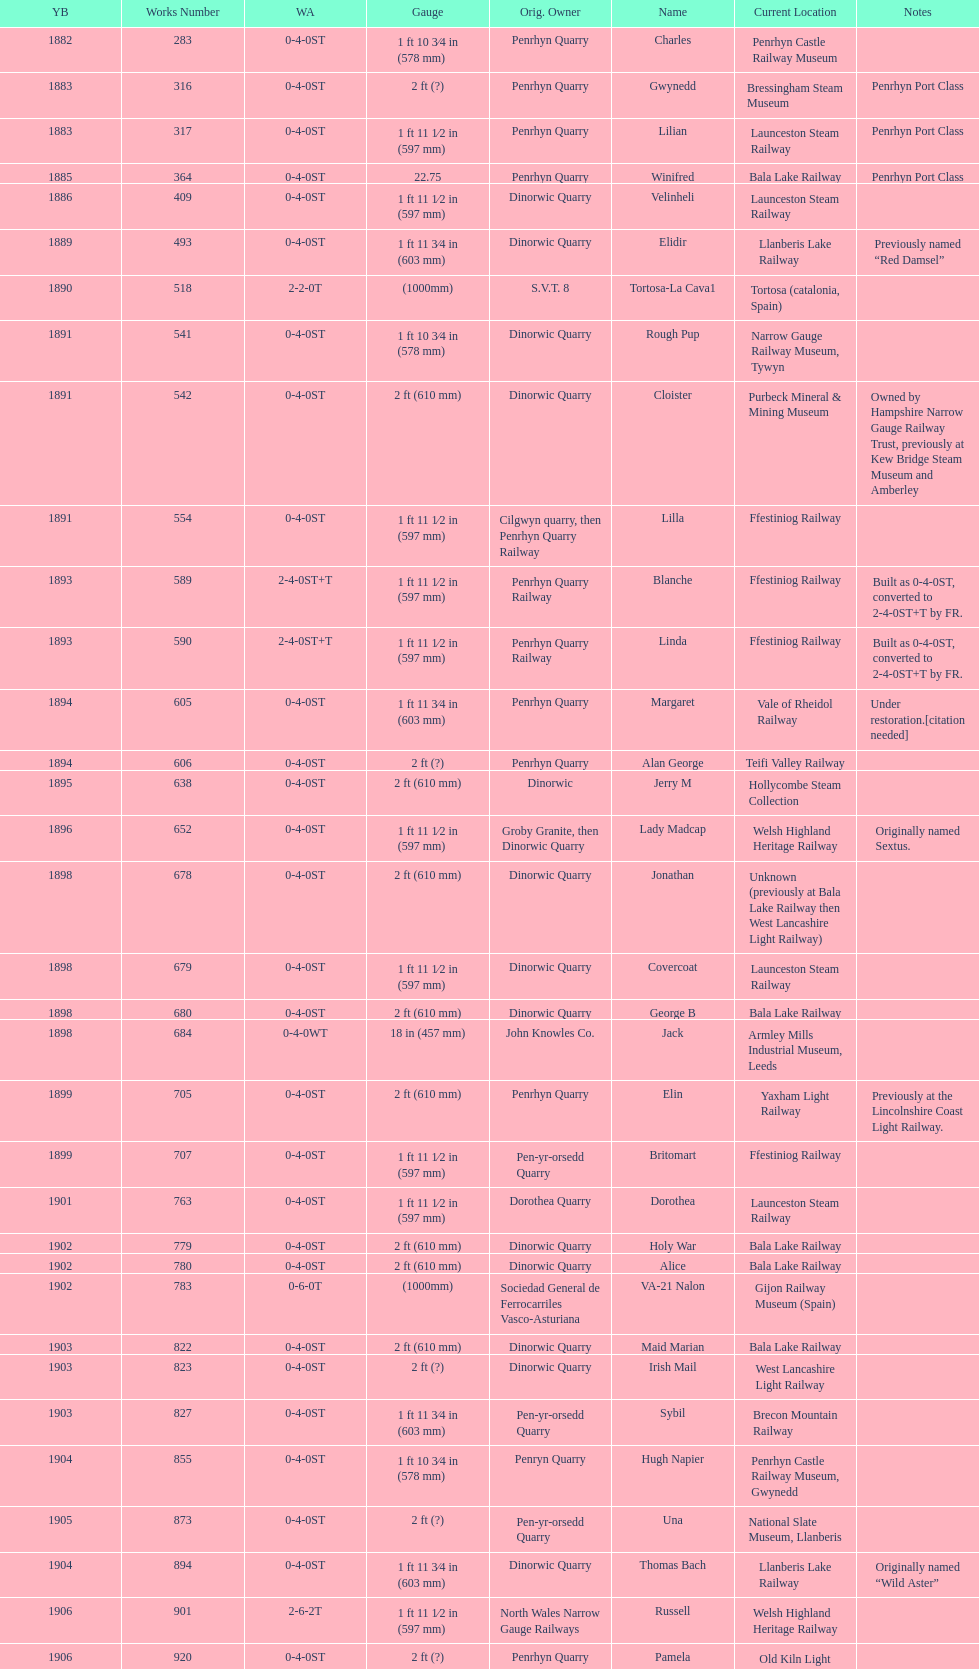What is the name of the last locomotive to be located at the bressingham steam museum? Gwynedd. Would you mind parsing the complete table? {'header': ['YB', 'Works Number', 'WA', 'Gauge', 'Orig. Owner', 'Name', 'Current Location', 'Notes'], 'rows': [['1882', '283', '0-4-0ST', '1\xa0ft 10\xa03⁄4\xa0in (578\xa0mm)', 'Penrhyn Quarry', 'Charles', 'Penrhyn Castle Railway Museum', ''], ['1883', '316', '0-4-0ST', '2\xa0ft (?)', 'Penrhyn Quarry', 'Gwynedd', 'Bressingham Steam Museum', 'Penrhyn Port Class'], ['1883', '317', '0-4-0ST', '1\xa0ft 11\xa01⁄2\xa0in (597\xa0mm)', 'Penrhyn Quarry', 'Lilian', 'Launceston Steam Railway', 'Penrhyn Port Class'], ['1885', '364', '0-4-0ST', '22.75', 'Penrhyn Quarry', 'Winifred', 'Bala Lake Railway', 'Penrhyn Port Class'], ['1886', '409', '0-4-0ST', '1\xa0ft 11\xa01⁄2\xa0in (597\xa0mm)', 'Dinorwic Quarry', 'Velinheli', 'Launceston Steam Railway', ''], ['1889', '493', '0-4-0ST', '1\xa0ft 11\xa03⁄4\xa0in (603\xa0mm)', 'Dinorwic Quarry', 'Elidir', 'Llanberis Lake Railway', 'Previously named “Red Damsel”'], ['1890', '518', '2-2-0T', '(1000mm)', 'S.V.T. 8', 'Tortosa-La Cava1', 'Tortosa (catalonia, Spain)', ''], ['1891', '541', '0-4-0ST', '1\xa0ft 10\xa03⁄4\xa0in (578\xa0mm)', 'Dinorwic Quarry', 'Rough Pup', 'Narrow Gauge Railway Museum, Tywyn', ''], ['1891', '542', '0-4-0ST', '2\xa0ft (610\xa0mm)', 'Dinorwic Quarry', 'Cloister', 'Purbeck Mineral & Mining Museum', 'Owned by Hampshire Narrow Gauge Railway Trust, previously at Kew Bridge Steam Museum and Amberley'], ['1891', '554', '0-4-0ST', '1\xa0ft 11\xa01⁄2\xa0in (597\xa0mm)', 'Cilgwyn quarry, then Penrhyn Quarry Railway', 'Lilla', 'Ffestiniog Railway', ''], ['1893', '589', '2-4-0ST+T', '1\xa0ft 11\xa01⁄2\xa0in (597\xa0mm)', 'Penrhyn Quarry Railway', 'Blanche', 'Ffestiniog Railway', 'Built as 0-4-0ST, converted to 2-4-0ST+T by FR.'], ['1893', '590', '2-4-0ST+T', '1\xa0ft 11\xa01⁄2\xa0in (597\xa0mm)', 'Penrhyn Quarry Railway', 'Linda', 'Ffestiniog Railway', 'Built as 0-4-0ST, converted to 2-4-0ST+T by FR.'], ['1894', '605', '0-4-0ST', '1\xa0ft 11\xa03⁄4\xa0in (603\xa0mm)', 'Penrhyn Quarry', 'Margaret', 'Vale of Rheidol Railway', 'Under restoration.[citation needed]'], ['1894', '606', '0-4-0ST', '2\xa0ft (?)', 'Penrhyn Quarry', 'Alan George', 'Teifi Valley Railway', ''], ['1895', '638', '0-4-0ST', '2\xa0ft (610\xa0mm)', 'Dinorwic', 'Jerry M', 'Hollycombe Steam Collection', ''], ['1896', '652', '0-4-0ST', '1\xa0ft 11\xa01⁄2\xa0in (597\xa0mm)', 'Groby Granite, then Dinorwic Quarry', 'Lady Madcap', 'Welsh Highland Heritage Railway', 'Originally named Sextus.'], ['1898', '678', '0-4-0ST', '2\xa0ft (610\xa0mm)', 'Dinorwic Quarry', 'Jonathan', 'Unknown (previously at Bala Lake Railway then West Lancashire Light Railway)', ''], ['1898', '679', '0-4-0ST', '1\xa0ft 11\xa01⁄2\xa0in (597\xa0mm)', 'Dinorwic Quarry', 'Covercoat', 'Launceston Steam Railway', ''], ['1898', '680', '0-4-0ST', '2\xa0ft (610\xa0mm)', 'Dinorwic Quarry', 'George B', 'Bala Lake Railway', ''], ['1898', '684', '0-4-0WT', '18\xa0in (457\xa0mm)', 'John Knowles Co.', 'Jack', 'Armley Mills Industrial Museum, Leeds', ''], ['1899', '705', '0-4-0ST', '2\xa0ft (610\xa0mm)', 'Penrhyn Quarry', 'Elin', 'Yaxham Light Railway', 'Previously at the Lincolnshire Coast Light Railway.'], ['1899', '707', '0-4-0ST', '1\xa0ft 11\xa01⁄2\xa0in (597\xa0mm)', 'Pen-yr-orsedd Quarry', 'Britomart', 'Ffestiniog Railway', ''], ['1901', '763', '0-4-0ST', '1\xa0ft 11\xa01⁄2\xa0in (597\xa0mm)', 'Dorothea Quarry', 'Dorothea', 'Launceston Steam Railway', ''], ['1902', '779', '0-4-0ST', '2\xa0ft (610\xa0mm)', 'Dinorwic Quarry', 'Holy War', 'Bala Lake Railway', ''], ['1902', '780', '0-4-0ST', '2\xa0ft (610\xa0mm)', 'Dinorwic Quarry', 'Alice', 'Bala Lake Railway', ''], ['1902', '783', '0-6-0T', '(1000mm)', 'Sociedad General de Ferrocarriles Vasco-Asturiana', 'VA-21 Nalon', 'Gijon Railway Museum (Spain)', ''], ['1903', '822', '0-4-0ST', '2\xa0ft (610\xa0mm)', 'Dinorwic Quarry', 'Maid Marian', 'Bala Lake Railway', ''], ['1903', '823', '0-4-0ST', '2\xa0ft (?)', 'Dinorwic Quarry', 'Irish Mail', 'West Lancashire Light Railway', ''], ['1903', '827', '0-4-0ST', '1\xa0ft 11\xa03⁄4\xa0in (603\xa0mm)', 'Pen-yr-orsedd Quarry', 'Sybil', 'Brecon Mountain Railway', ''], ['1904', '855', '0-4-0ST', '1\xa0ft 10\xa03⁄4\xa0in (578\xa0mm)', 'Penryn Quarry', 'Hugh Napier', 'Penrhyn Castle Railway Museum, Gwynedd', ''], ['1905', '873', '0-4-0ST', '2\xa0ft (?)', 'Pen-yr-orsedd Quarry', 'Una', 'National Slate Museum, Llanberis', ''], ['1904', '894', '0-4-0ST', '1\xa0ft 11\xa03⁄4\xa0in (603\xa0mm)', 'Dinorwic Quarry', 'Thomas Bach', 'Llanberis Lake Railway', 'Originally named “Wild Aster”'], ['1906', '901', '2-6-2T', '1\xa0ft 11\xa01⁄2\xa0in (597\xa0mm)', 'North Wales Narrow Gauge Railways', 'Russell', 'Welsh Highland Heritage Railway', ''], ['1906', '920', '0-4-0ST', '2\xa0ft (?)', 'Penrhyn Quarry', 'Pamela', 'Old Kiln Light Railway', ''], ['1909', '994', '0-4-0ST', '2\xa0ft (?)', 'Penrhyn Quarry', 'Bill Harvey', 'Bressingham Steam Museum', 'previously George Sholto'], ['1918', '1312', '4-6-0T', '1\xa0ft\xa011\xa01⁄2\xa0in (597\xa0mm)', 'British War Department\\nEFOP #203', '---', 'Pampas Safari, Gravataí, RS, Brazil', '[citation needed]'], ['1918\\nor\\n1921?', '1313', '0-6-2T', '3\xa0ft\xa03\xa03⁄8\xa0in (1,000\xa0mm)', 'British War Department\\nUsina Leão Utinga #1\\nUsina Laginha #1', '---', 'Usina Laginha, União dos Palmares, AL, Brazil', '[citation needed]'], ['1920', '1404', '0-4-0WT', '18\xa0in (457\xa0mm)', 'John Knowles Co.', 'Gwen', 'Richard Farmer current owner, Northridge, California, USA', ''], ['1922', '1429', '0-4-0ST', '2\xa0ft (610\xa0mm)', 'Dinorwic', 'Lady Joan', 'Bredgar and Wormshill Light Railway', ''], ['1922', '1430', '0-4-0ST', '1\xa0ft 11\xa03⁄4\xa0in (603\xa0mm)', 'Dinorwic Quarry', 'Dolbadarn', 'Llanberis Lake Railway', ''], ['1937', '1859', '0-4-2T', '2\xa0ft (?)', 'Umtwalumi Valley Estate, Natal', '16 Carlisle', 'South Tynedale Railway', ''], ['1940', '2075', '0-4-2T', '2\xa0ft (?)', 'Chaka’s Kraal Sugar Estates, Natal', 'Chaka’s Kraal No. 6', 'North Gloucestershire Railway', ''], ['1954', '3815', '2-6-2T', '2\xa0ft 6\xa0in (762\xa0mm)', 'Sierra Leone Government Railway', '14', 'Welshpool and Llanfair Light Railway', ''], ['1971', '3902', '0-4-2ST', '2\xa0ft (610\xa0mm)', 'Trangkil Sugar Mill, Indonesia', 'Trangkil No.4', 'Statfold Barn Railway', 'Converted from 750\xa0mm (2\xa0ft\xa05\xa01⁄2\xa0in) gauge. Last steam locomotive to be built by Hunslet, and the last industrial steam locomotive built in Britain.']]} 